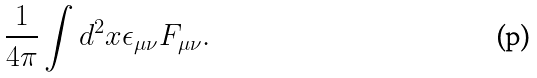<formula> <loc_0><loc_0><loc_500><loc_500>\frac { 1 } { 4 \pi } \int d ^ { 2 } x \epsilon _ { \mu \nu } F _ { \mu \nu } .</formula> 